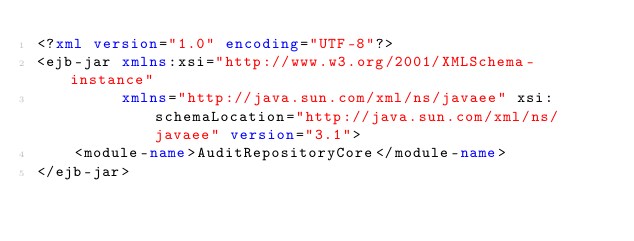<code> <loc_0><loc_0><loc_500><loc_500><_XML_><?xml version="1.0" encoding="UTF-8"?>
<ejb-jar xmlns:xsi="http://www.w3.org/2001/XMLSchema-instance"
         xmlns="http://java.sun.com/xml/ns/javaee" xsi:schemaLocation="http://java.sun.com/xml/ns/javaee" version="3.1">
    <module-name>AuditRepositoryCore</module-name>
</ejb-jar></code> 